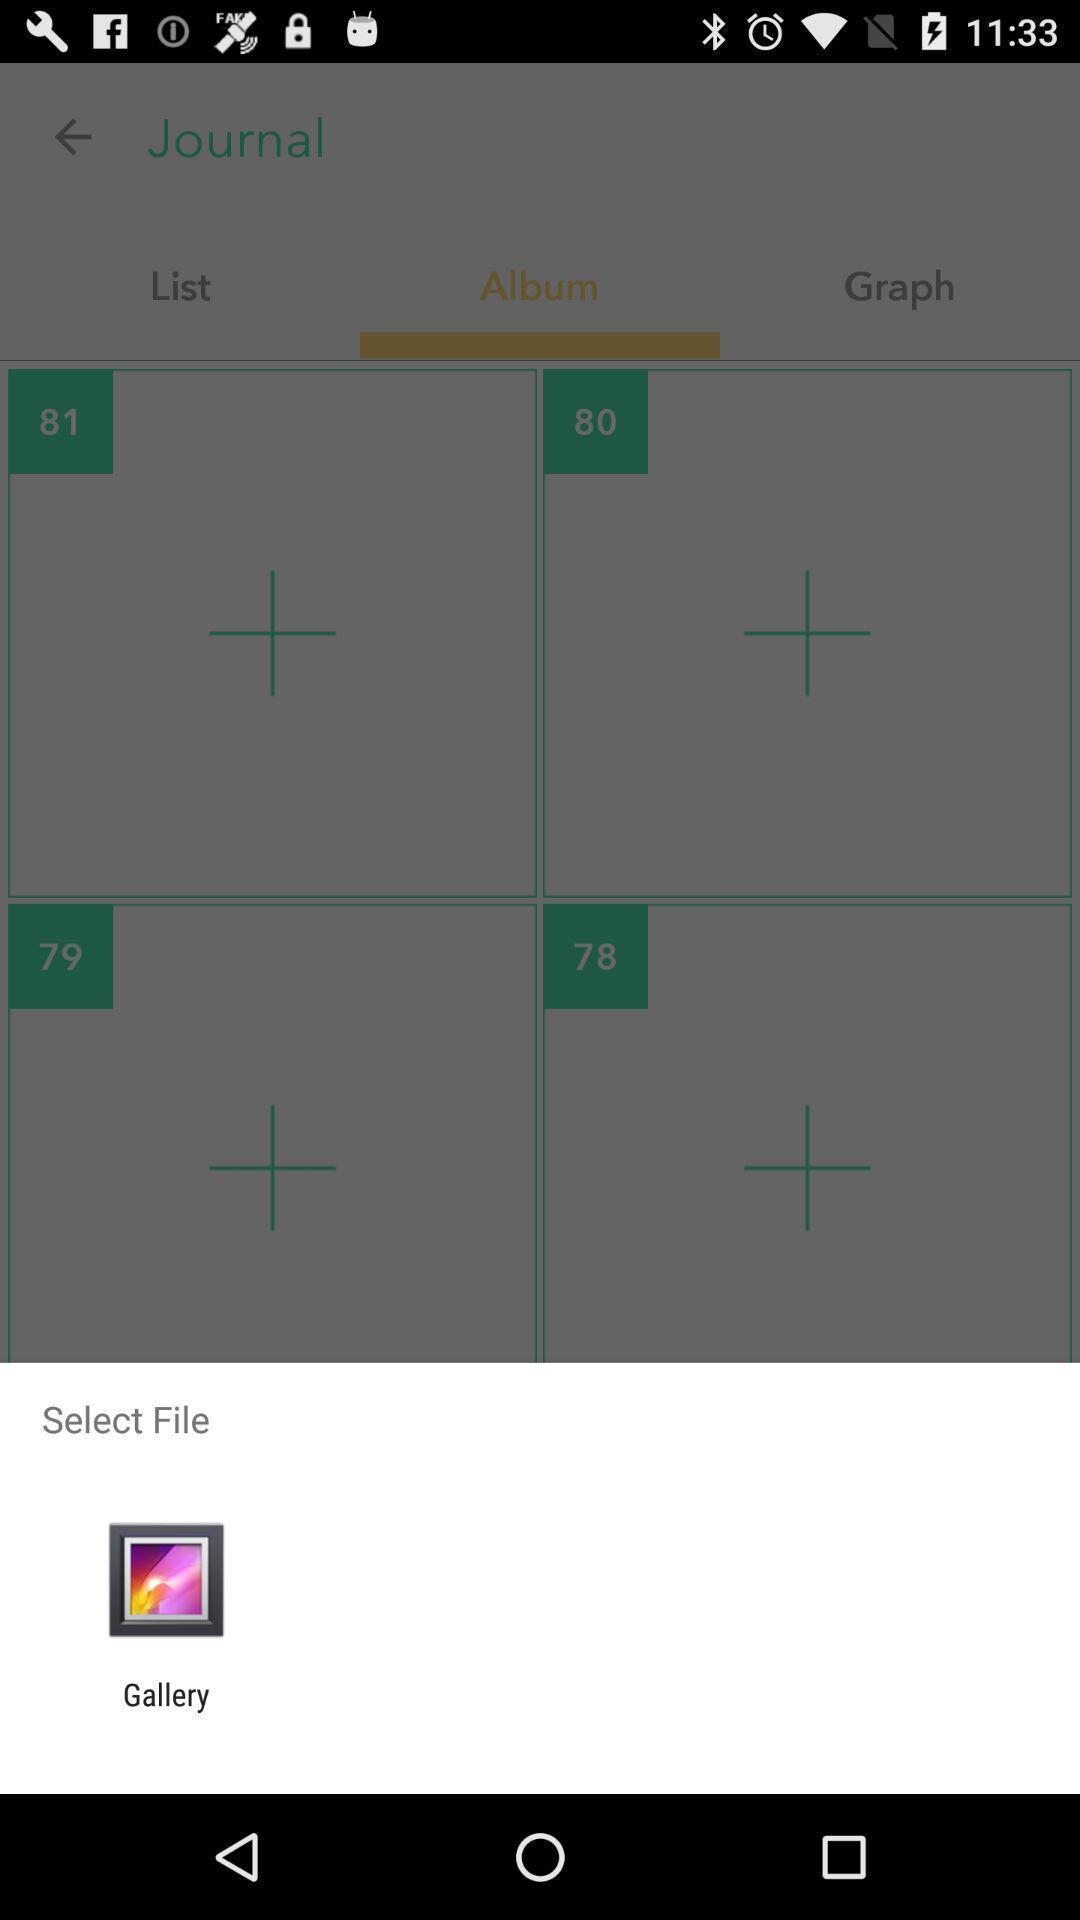Describe the content in this image. Pop up to select file through application. 